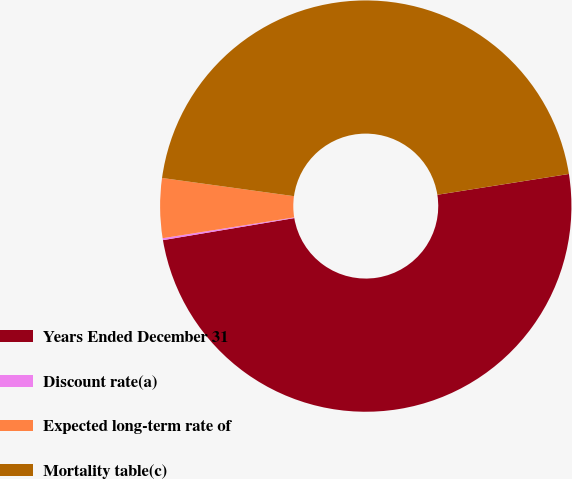Convert chart to OTSL. <chart><loc_0><loc_0><loc_500><loc_500><pie_chart><fcel>Years Ended December 31<fcel>Discount rate(a)<fcel>Expected long-term rate of<fcel>Mortality table(c)<nl><fcel>49.85%<fcel>0.15%<fcel>4.68%<fcel>45.32%<nl></chart> 